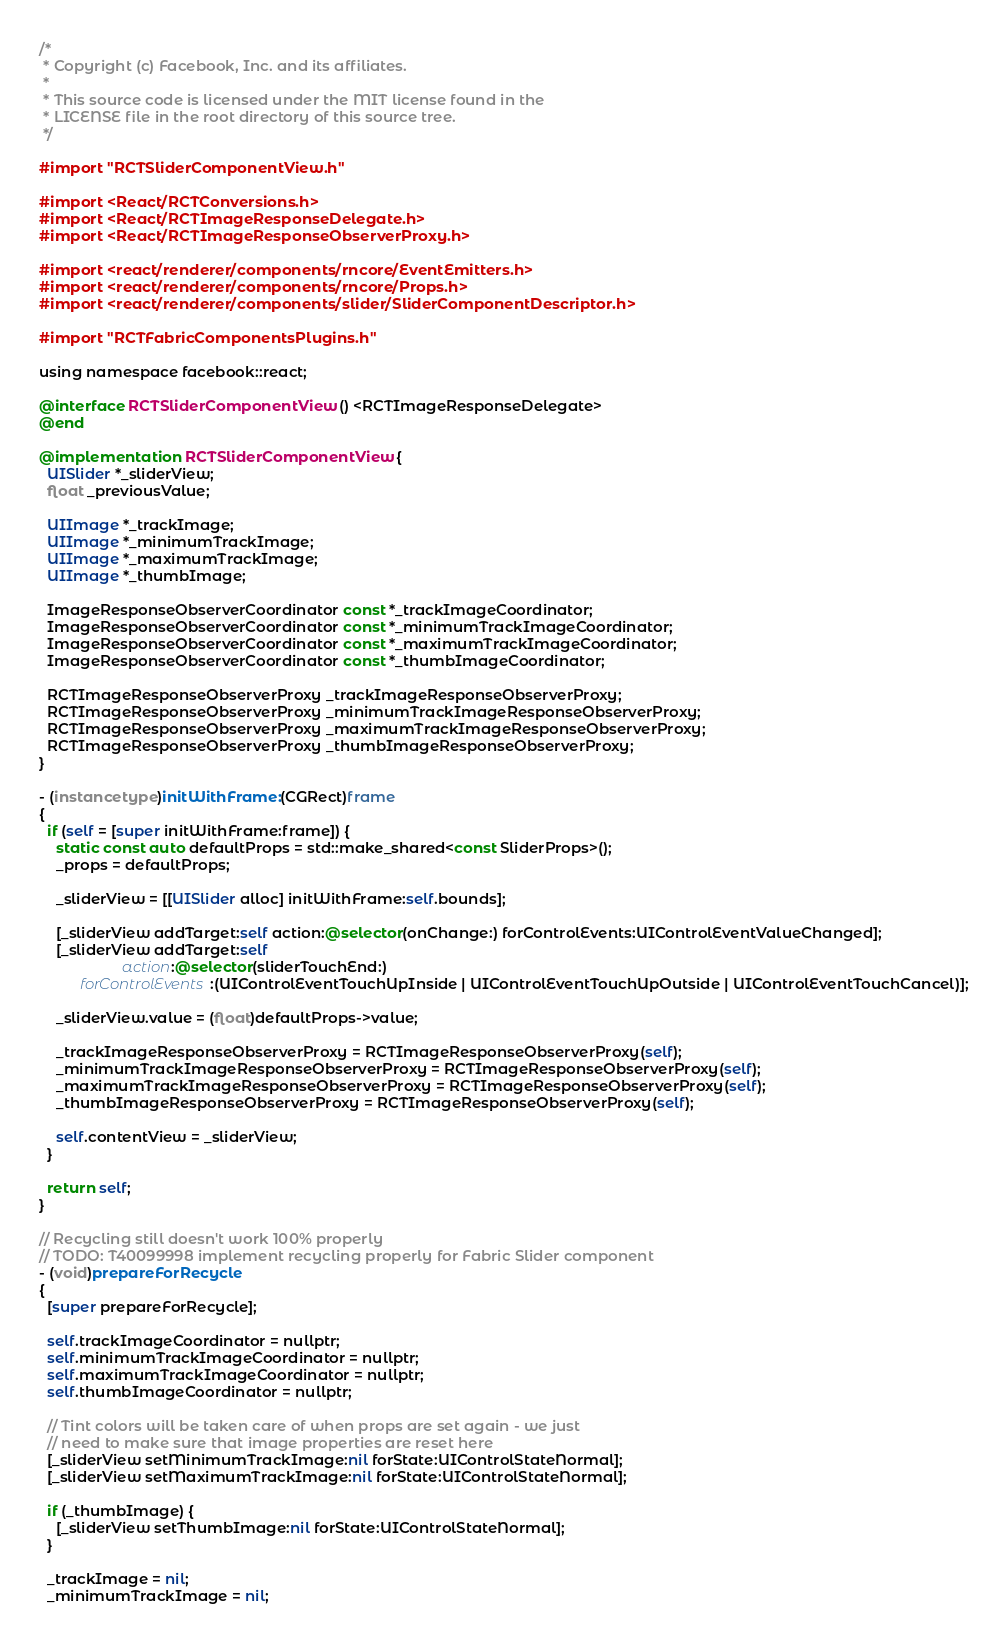<code> <loc_0><loc_0><loc_500><loc_500><_ObjectiveC_>/*
 * Copyright (c) Facebook, Inc. and its affiliates.
 *
 * This source code is licensed under the MIT license found in the
 * LICENSE file in the root directory of this source tree.
 */

#import "RCTSliderComponentView.h"

#import <React/RCTConversions.h>
#import <React/RCTImageResponseDelegate.h>
#import <React/RCTImageResponseObserverProxy.h>

#import <react/renderer/components/rncore/EventEmitters.h>
#import <react/renderer/components/rncore/Props.h>
#import <react/renderer/components/slider/SliderComponentDescriptor.h>

#import "RCTFabricComponentsPlugins.h"

using namespace facebook::react;

@interface RCTSliderComponentView () <RCTImageResponseDelegate>
@end

@implementation RCTSliderComponentView {
  UISlider *_sliderView;
  float _previousValue;

  UIImage *_trackImage;
  UIImage *_minimumTrackImage;
  UIImage *_maximumTrackImage;
  UIImage *_thumbImage;

  ImageResponseObserverCoordinator const *_trackImageCoordinator;
  ImageResponseObserverCoordinator const *_minimumTrackImageCoordinator;
  ImageResponseObserverCoordinator const *_maximumTrackImageCoordinator;
  ImageResponseObserverCoordinator const *_thumbImageCoordinator;

  RCTImageResponseObserverProxy _trackImageResponseObserverProxy;
  RCTImageResponseObserverProxy _minimumTrackImageResponseObserverProxy;
  RCTImageResponseObserverProxy _maximumTrackImageResponseObserverProxy;
  RCTImageResponseObserverProxy _thumbImageResponseObserverProxy;
}

- (instancetype)initWithFrame:(CGRect)frame
{
  if (self = [super initWithFrame:frame]) {
    static const auto defaultProps = std::make_shared<const SliderProps>();
    _props = defaultProps;

    _sliderView = [[UISlider alloc] initWithFrame:self.bounds];

    [_sliderView addTarget:self action:@selector(onChange:) forControlEvents:UIControlEventValueChanged];
    [_sliderView addTarget:self
                    action:@selector(sliderTouchEnd:)
          forControlEvents:(UIControlEventTouchUpInside | UIControlEventTouchUpOutside | UIControlEventTouchCancel)];

    _sliderView.value = (float)defaultProps->value;

    _trackImageResponseObserverProxy = RCTImageResponseObserverProxy(self);
    _minimumTrackImageResponseObserverProxy = RCTImageResponseObserverProxy(self);
    _maximumTrackImageResponseObserverProxy = RCTImageResponseObserverProxy(self);
    _thumbImageResponseObserverProxy = RCTImageResponseObserverProxy(self);

    self.contentView = _sliderView;
  }

  return self;
}

// Recycling still doesn't work 100% properly
// TODO: T40099998 implement recycling properly for Fabric Slider component
- (void)prepareForRecycle
{
  [super prepareForRecycle];

  self.trackImageCoordinator = nullptr;
  self.minimumTrackImageCoordinator = nullptr;
  self.maximumTrackImageCoordinator = nullptr;
  self.thumbImageCoordinator = nullptr;

  // Tint colors will be taken care of when props are set again - we just
  // need to make sure that image properties are reset here
  [_sliderView setMinimumTrackImage:nil forState:UIControlStateNormal];
  [_sliderView setMaximumTrackImage:nil forState:UIControlStateNormal];

  if (_thumbImage) {
    [_sliderView setThumbImage:nil forState:UIControlStateNormal];
  }

  _trackImage = nil;
  _minimumTrackImage = nil;</code> 